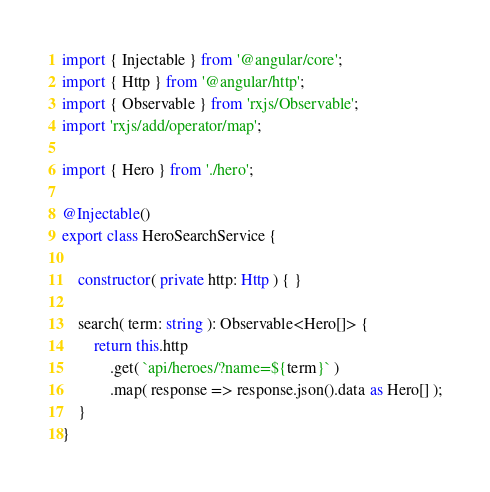Convert code to text. <code><loc_0><loc_0><loc_500><loc_500><_TypeScript_>import { Injectable } from '@angular/core';
import { Http } from '@angular/http';
import { Observable } from 'rxjs/Observable';
import 'rxjs/add/operator/map';

import { Hero } from './hero';

@Injectable()
export class HeroSearchService {

    constructor( private http: Http ) { }

    search( term: string ): Observable<Hero[]> {
        return this.http
            .get( `api/heroes/?name=${term}` )
            .map( response => response.json().data as Hero[] );
    }
}</code> 